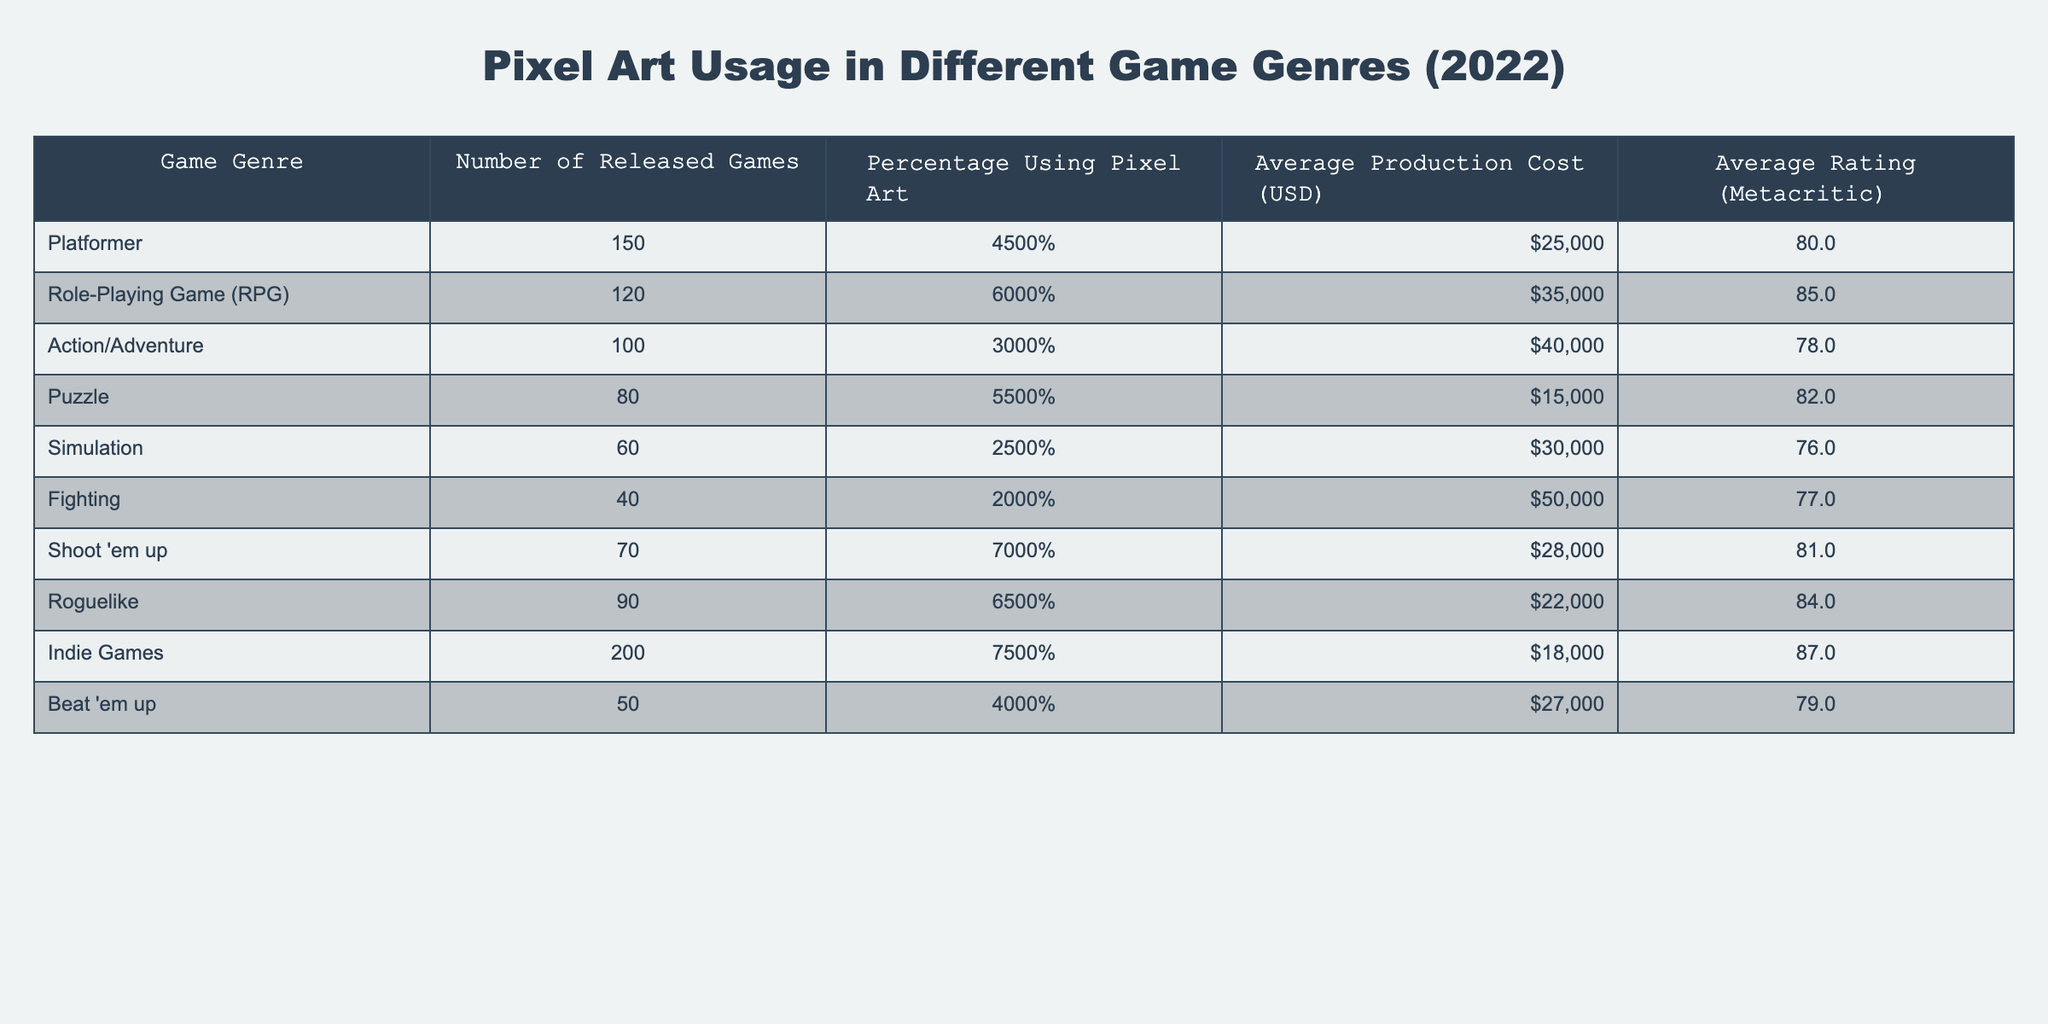What's the game genre with the highest percentage of pixel art usage? By examining the "Percentage Using Pixel Art" column, we see that "Indie Games" has the highest value at 75%.
Answer: Indie Games Which game genre has the lowest average production cost? Looking at the "Average Production Cost" column, "Puzzle" has the lowest average at 15,000 USD.
Answer: Puzzle What is the average rating of RPGs? The average rating for "Role-Playing Game (RPG)" is presented on the table as 85.
Answer: 85 How many more games were released in the Platformer genre compared to the Fighting genre? The number of released games for "Platformer" is 150, while "Fighting" has 40. The difference is 150 - 40 = 110.
Answer: 110 Is it true that Simulation games have a higher average rating than Action/Adventure games? The average rating for "Simulation" is 76 and for "Action/Adventure" it is 78. Since 76 is not greater than 78, the statement is false.
Answer: No What is the total number of games released across all genres that use pixel art? To find the total, we look at the "Number of Released Games" column and sum the numbers from each genre which leads to the total of 150 + 120 + 100 + 80 + 60 + 40 + 70 + 90 + 200 + 50 = 1060.
Answer: 1060 Which genre has both a relatively high production cost and a low percentage of pixel art usage? Noting the production costs and percentages, "Fighting" stands out with a cost of 50,000 USD and a pixel art usage of only 20%.
Answer: Fighting What percentage of indie games used pixel art? From the table, the "Percentage Using Pixel Art" for the "Indie Games" genre is given as 75%.
Answer: 75% What is the average production cost for all genres combined? First, we need to sum the average production costs from each genre: (25000 + 35000 + 40000 + 15000 + 30000 + 50000 + 28000 + 22000 + 18000 + 27000) = 235000. There are 10 genres, so we divide by 10 to get 235000 / 10 = 23500 USD.
Answer: 23500 